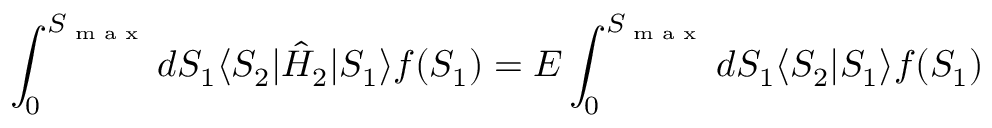<formula> <loc_0><loc_0><loc_500><loc_500>\int _ { 0 } ^ { S _ { \max } } d S _ { 1 } \langle S _ { 2 } | \hat { H } _ { 2 } | S _ { 1 } \rangle f ( S _ { 1 } ) = E \int _ { 0 } ^ { S _ { \max } } d S _ { 1 } \langle S _ { 2 } | S _ { 1 } \rangle f ( S _ { 1 } )</formula> 